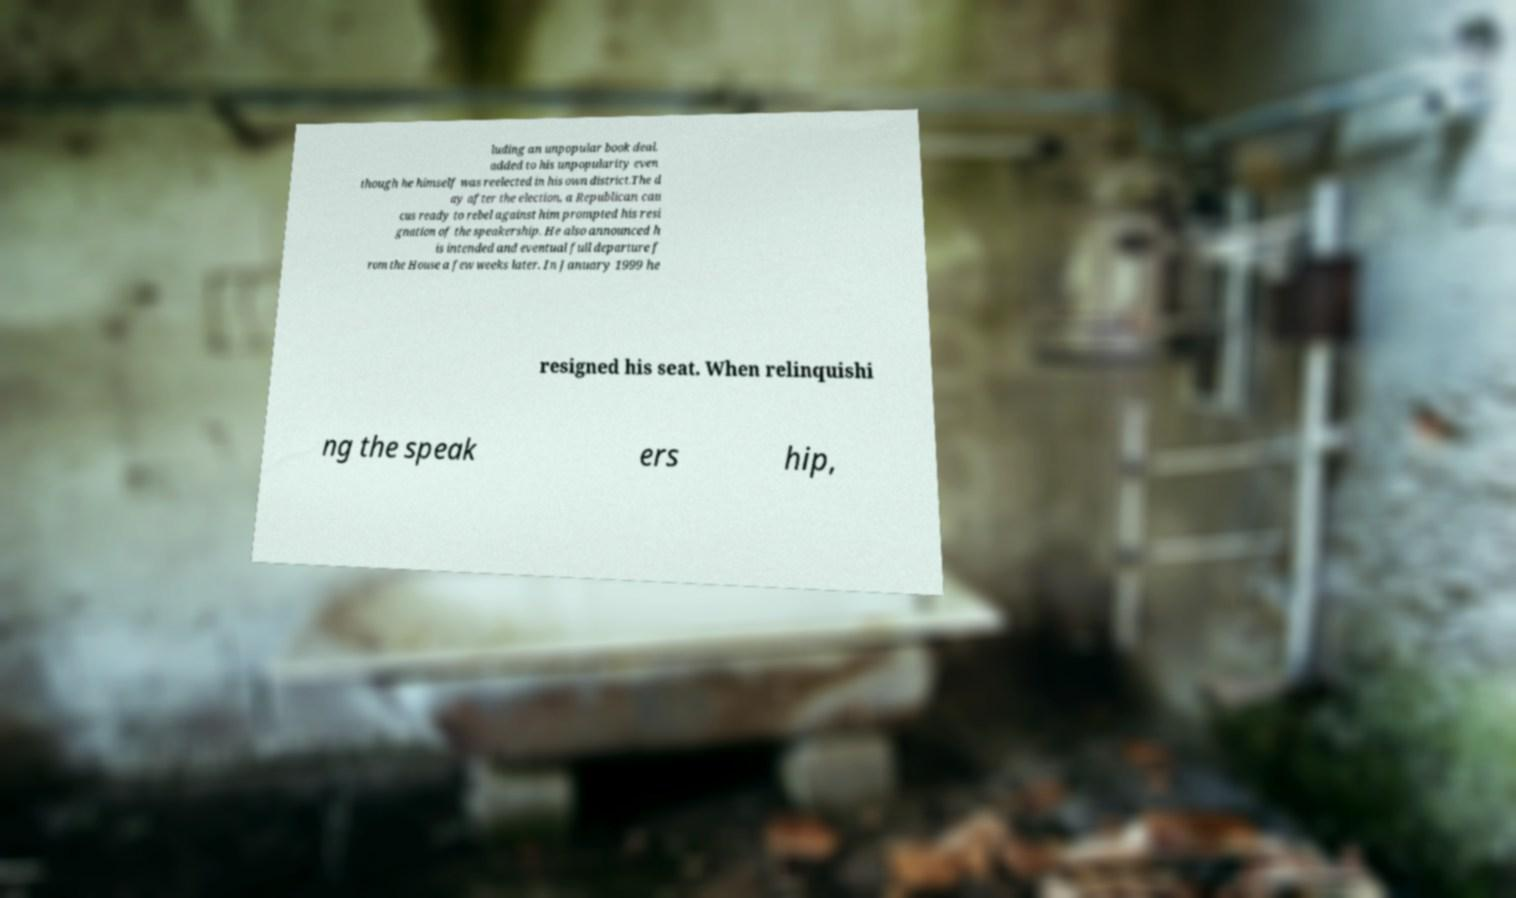Could you extract and type out the text from this image? luding an unpopular book deal, added to his unpopularity even though he himself was reelected in his own district.The d ay after the election, a Republican cau cus ready to rebel against him prompted his resi gnation of the speakership. He also announced h is intended and eventual full departure f rom the House a few weeks later. In January 1999 he resigned his seat. When relinquishi ng the speak ers hip, 